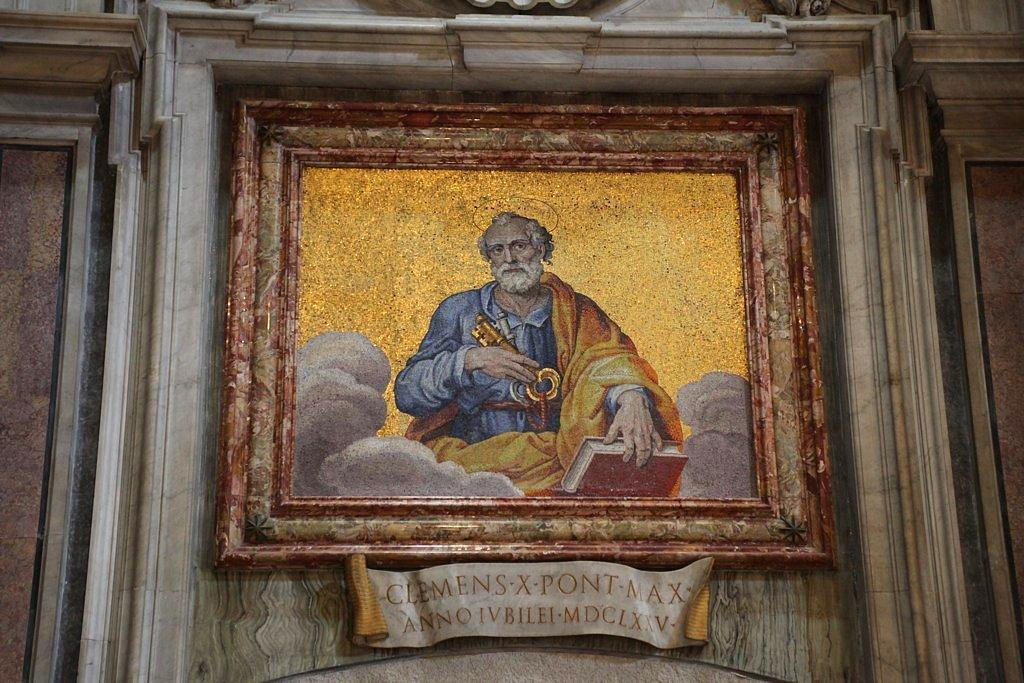<image>
Present a compact description of the photo's key features. A painting with text underneath that reads CLEMENS-X-PONT-MAX ANNOIVBILEI-MDCLXXV- 